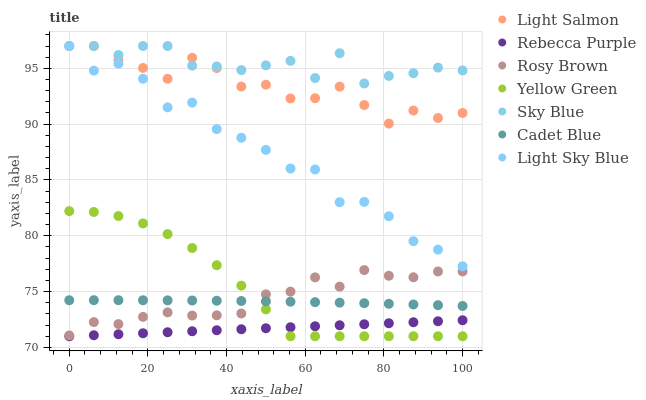Does Rebecca Purple have the minimum area under the curve?
Answer yes or no. Yes. Does Sky Blue have the maximum area under the curve?
Answer yes or no. Yes. Does Cadet Blue have the minimum area under the curve?
Answer yes or no. No. Does Cadet Blue have the maximum area under the curve?
Answer yes or no. No. Is Rebecca Purple the smoothest?
Answer yes or no. Yes. Is Light Sky Blue the roughest?
Answer yes or no. Yes. Is Cadet Blue the smoothest?
Answer yes or no. No. Is Cadet Blue the roughest?
Answer yes or no. No. Does Yellow Green have the lowest value?
Answer yes or no. Yes. Does Cadet Blue have the lowest value?
Answer yes or no. No. Does Sky Blue have the highest value?
Answer yes or no. Yes. Does Cadet Blue have the highest value?
Answer yes or no. No. Is Rosy Brown less than Light Salmon?
Answer yes or no. Yes. Is Sky Blue greater than Yellow Green?
Answer yes or no. Yes. Does Light Sky Blue intersect Light Salmon?
Answer yes or no. Yes. Is Light Sky Blue less than Light Salmon?
Answer yes or no. No. Is Light Sky Blue greater than Light Salmon?
Answer yes or no. No. Does Rosy Brown intersect Light Salmon?
Answer yes or no. No. 